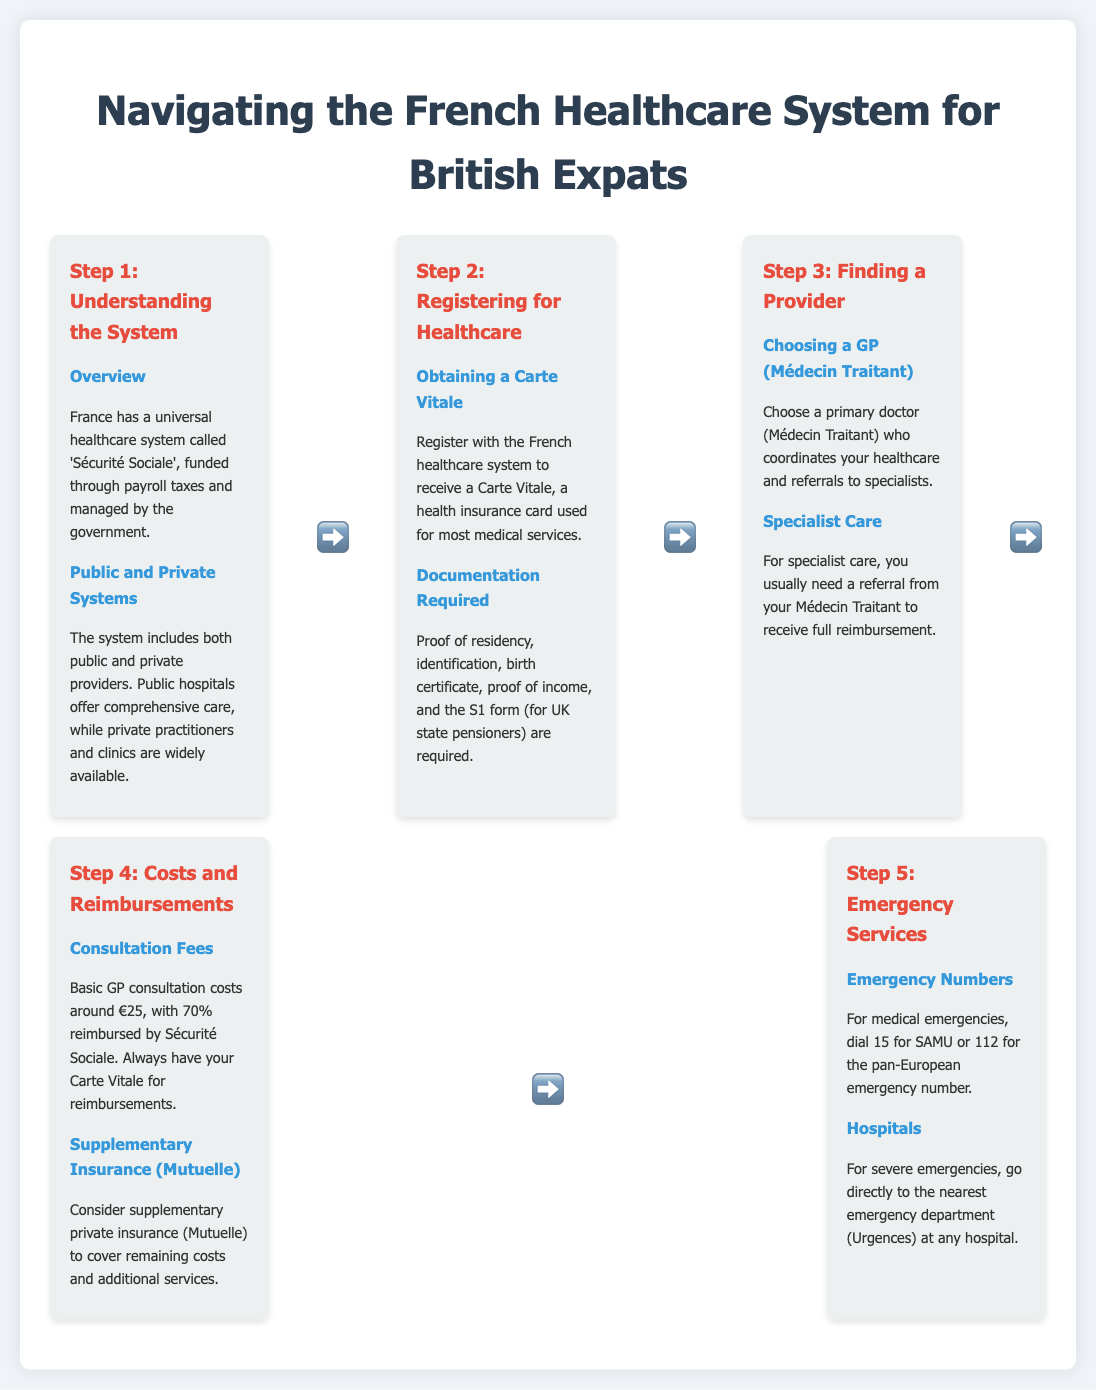What is the French universal healthcare system called? The document states that the French universal healthcare system is called 'Sécurité Sociale'.
Answer: 'Sécurité Sociale' What card do you receive after registering for the French healthcare system? The infographic mentions that you receive a Carte Vitale after registering.
Answer: Carte Vitale What percentage of GP consultation fees is reimbursed by Sécurité Sociale? The consultation fees are reimbursed by 70% as stated in the document.
Answer: 70% Which emergency number should you dial for medical emergencies? The document lists the number 15 for medical emergencies.
Answer: 15 What is required to register in the French healthcare system? The document outlines that proof of residency, identification, and other documents are required.
Answer: Proof of residency, identification, birth certificate, proof of income, S1 form How do you receive full reimbursement for specialist care? The infographic explains that you usually need a referral from your Médecin Traitant for full reimbursement.
Answer: Referral from Médecin Traitant What type of insurance can cover remaining costs not covered by Sécurité Sociale? The document suggests considering a supplementary private insurance called Mutuelle.
Answer: Mutuelle What should you always have for reimbursements? The text emphasizes that you should always have your Carte Vitale for reimbursements.
Answer: Carte Vitale What is the term for a primary doctor in the French healthcare system? The document refers to the primary doctor as Médecin Traitant.
Answer: Médecin Traitant 